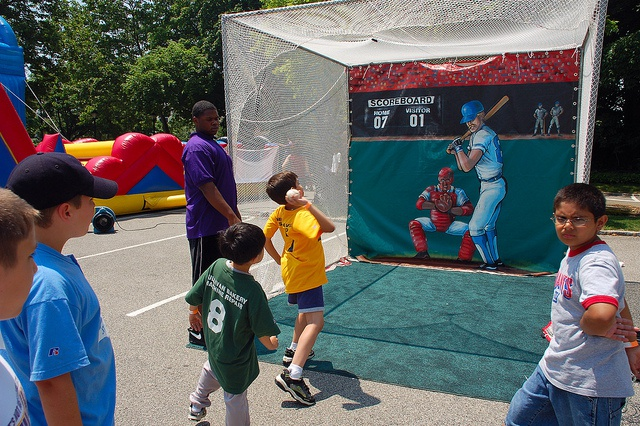Describe the objects in this image and their specific colors. I can see people in teal, blue, black, maroon, and navy tones, people in teal, gray, maroon, and black tones, people in teal, black, gray, and darkgray tones, people in teal, red, black, brown, and orange tones, and people in teal, black, navy, maroon, and gray tones in this image. 